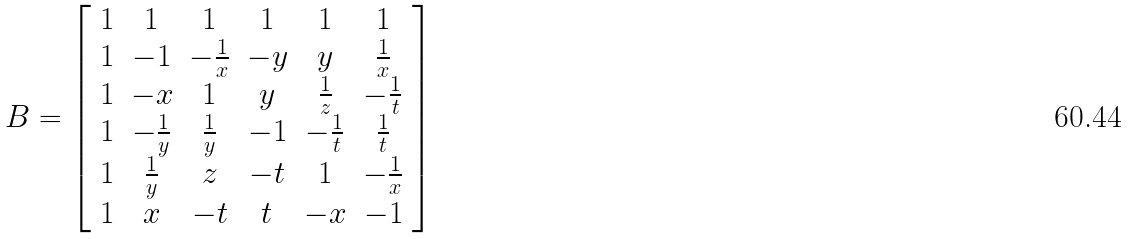<formula> <loc_0><loc_0><loc_500><loc_500>B = \left [ \begin{array} { c c c c c c } 1 & 1 & 1 & 1 & 1 & 1 \\ 1 & - 1 & - \frac { 1 } { x } & - y & y & \frac { 1 } { x } \\ 1 & - x & 1 & y & \frac { 1 } { z } & - \frac { 1 } { t } \\ 1 & - \frac { 1 } { y } & \frac { 1 } { y } & - 1 & - \frac { 1 } { t } & \frac { 1 } { t } \\ 1 & \frac { 1 } { y } & z & - t & 1 & - \frac { 1 } { x } \\ 1 & x & - t & t & - x & - 1 \end{array} \right ]</formula> 